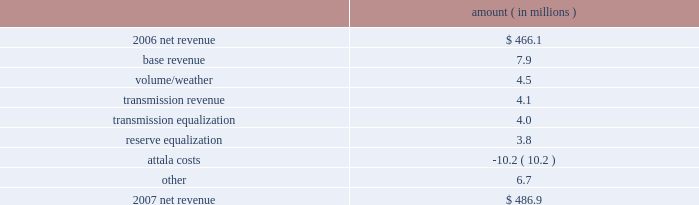Entergy mississippi , inc .
Management's financial discussion and analysis the net wholesale revenue variance is primarily due to lower profit on joint account sales and reduced capacity revenue from the municipal energy agency of mississippi .
Gross operating revenues , fuel and purchased power expenses , and other regulatory charges gross operating revenues increased primarily due to an increase of $ 152.5 million in fuel cost recovery revenues due to higher fuel rates , partially offset by a decrease of $ 43 million in gross wholesale revenues due to a decrease in net generation and purchases in excess of decreased net area demand resulting in less energy available for resale sales coupled with a decrease in system agreement remedy receipts .
Fuel and purchased power expenses increased primarily due to increases in the average market prices of natural gas and purchased power , partially offset by decreased demand and decreased recovery from customers of deferred fuel costs .
Other regulatory charges increased primarily due to increased recovery through the grand gulf rider of grand gulf capacity costs due to higher rates and increased recovery of costs associated with the power management recovery rider .
There is no material effect on net income due to quarterly adjustments to the power management recovery rider .
2007 compared to 2006 net revenue consists of operating revenues net of : 1 ) fuel , fuel-related expenses , and gas purchased for resale , 2 ) purchased power expenses , and 3 ) other regulatory charges ( credits ) .
Following is an analysis of the change in net revenue comparing 2007 to 2006 .
Amount ( in millions ) .
The base revenue variance is primarily due to a formula rate plan increase effective july 2007 .
The formula rate plan filing is discussed further in "state and local rate regulation" below .
The volume/weather variance is primarily due to increased electricity usage primarily in the residential and commercial sectors , including the effect of more favorable weather on billed electric sales in 2007 compared to 2006 .
Billed electricity usage increased 214 gwh .
The increase in usage was partially offset by decreased usage in the industrial sector .
The transmission revenue variance is due to higher rates and the addition of new transmission customers in late 2006 .
The transmission equalization variance is primarily due to a revision made in 2006 of transmission equalization receipts among entergy companies .
The reserve equalization variance is primarily due to a revision in 2006 of reserve equalization payments among entergy companies due to a ferc ruling regarding the inclusion of interruptible loads in reserve .
What percent of the change in revenue was due to volume/weather? 
Computations: (4.5 / (486.9 - 466.1))
Answer: 0.21635. 